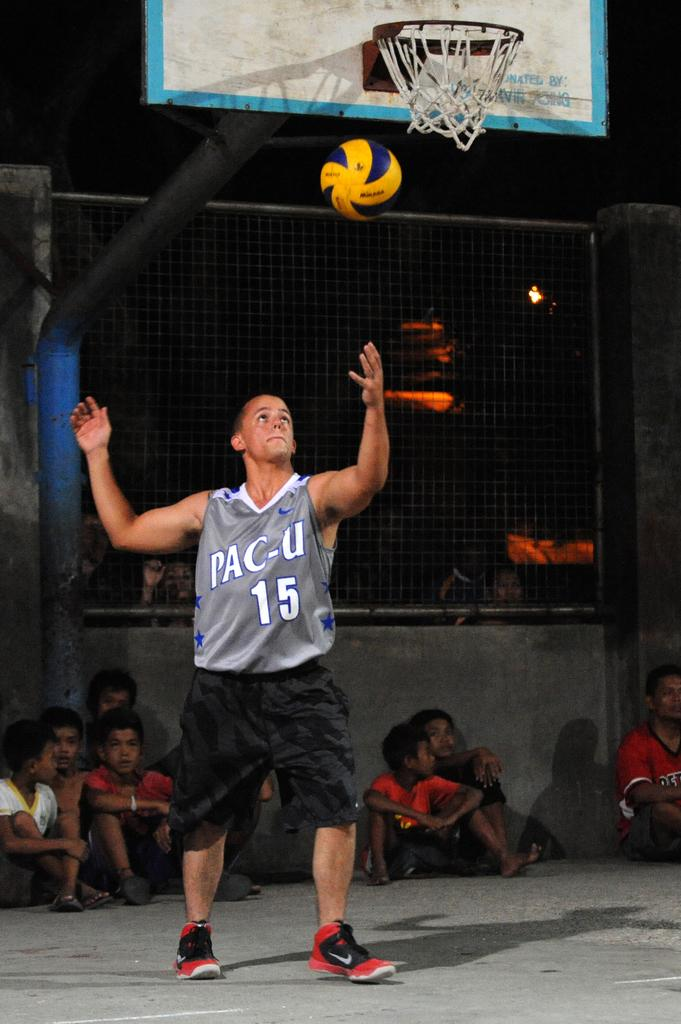Provide a one-sentence caption for the provided image. a basketball player with the number 15 on it that says pac-u. 